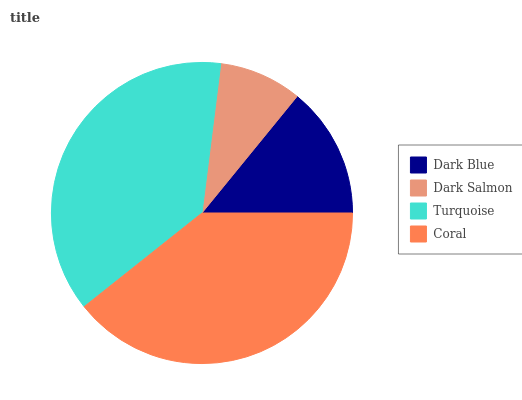Is Dark Salmon the minimum?
Answer yes or no. Yes. Is Coral the maximum?
Answer yes or no. Yes. Is Turquoise the minimum?
Answer yes or no. No. Is Turquoise the maximum?
Answer yes or no. No. Is Turquoise greater than Dark Salmon?
Answer yes or no. Yes. Is Dark Salmon less than Turquoise?
Answer yes or no. Yes. Is Dark Salmon greater than Turquoise?
Answer yes or no. No. Is Turquoise less than Dark Salmon?
Answer yes or no. No. Is Turquoise the high median?
Answer yes or no. Yes. Is Dark Blue the low median?
Answer yes or no. Yes. Is Dark Salmon the high median?
Answer yes or no. No. Is Dark Salmon the low median?
Answer yes or no. No. 